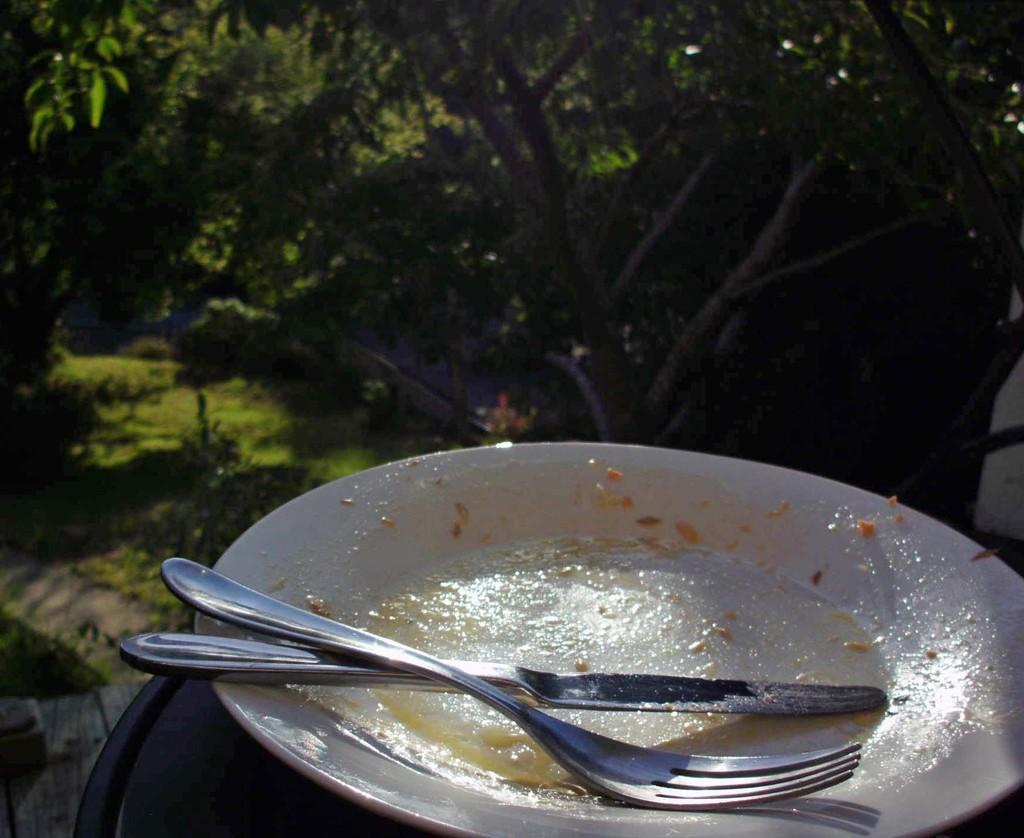What is on the plate in the image? There is a knife and a fork on the plate in the image. What can be seen in the background of the image? There are trees and grassland in the background of the image. What type of mine is visible in the image? There is no mine present in the image. How does the base of the plate look like in the image? The base of the plate is not visible in the image, as the focus is on the knife and fork on top of the plate. 